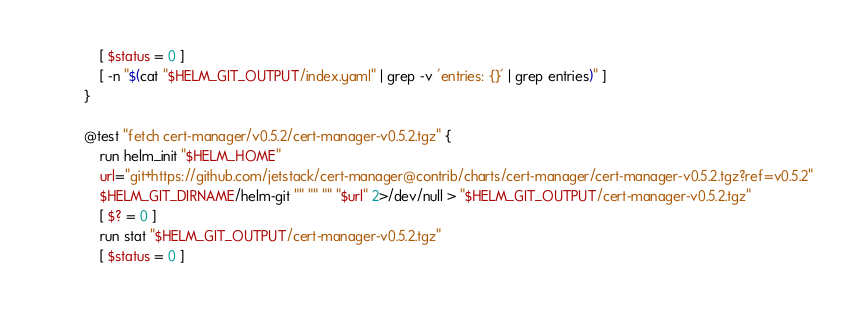<code> <loc_0><loc_0><loc_500><loc_500><_Bash_>    [ $status = 0 ]
    [ -n "$(cat "$HELM_GIT_OUTPUT/index.yaml" | grep -v 'entries: {}' | grep entries)" ]
}

@test "fetch cert-manager/v0.5.2/cert-manager-v0.5.2.tgz" {
    run helm_init "$HELM_HOME"
    url="git+https://github.com/jetstack/cert-manager@contrib/charts/cert-manager/cert-manager-v0.5.2.tgz?ref=v0.5.2"
    $HELM_GIT_DIRNAME/helm-git "" "" "" "$url" 2>/dev/null > "$HELM_GIT_OUTPUT/cert-manager-v0.5.2.tgz"
    [ $? = 0 ]
    run stat "$HELM_GIT_OUTPUT/cert-manager-v0.5.2.tgz"
    [ $status = 0 ]</code> 